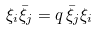Convert formula to latex. <formula><loc_0><loc_0><loc_500><loc_500>\xi _ { i } \bar { \xi } _ { j } = q \, \bar { \xi } _ { j } \xi _ { i }</formula> 